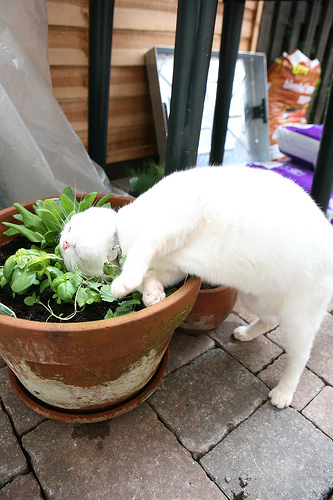What animal is the collar on? The collar is on a cat. 